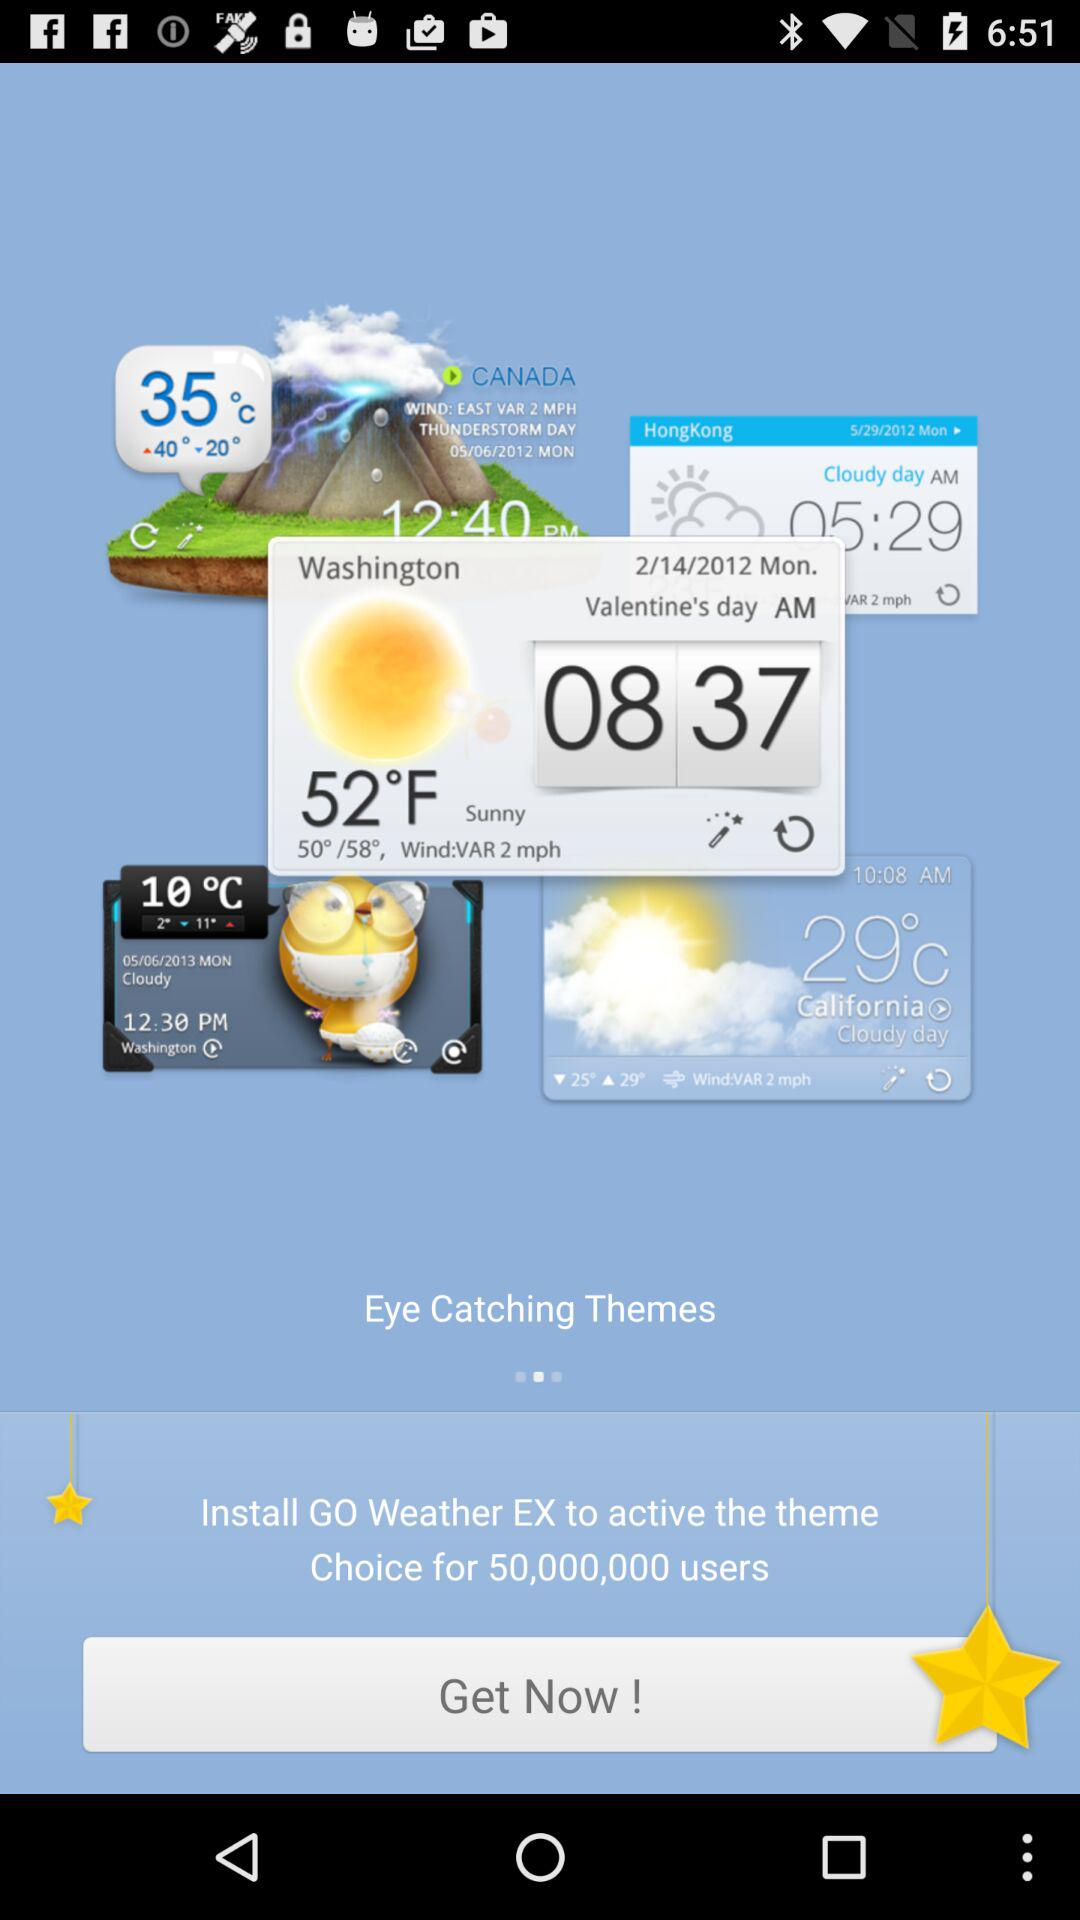How many users can install the GoWeatherEx application?
When the provided information is insufficient, respond with <no answer>. <no answer> 